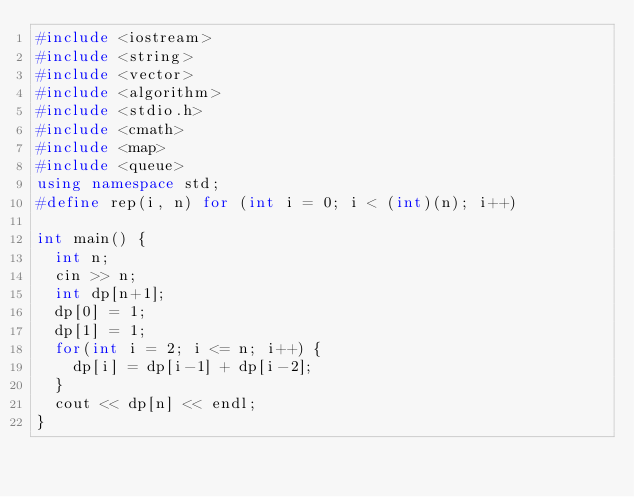<code> <loc_0><loc_0><loc_500><loc_500><_C++_>#include <iostream>
#include <string>
#include <vector>
#include <algorithm>
#include <stdio.h>
#include <cmath>
#include <map>
#include <queue>
using namespace std;
#define rep(i, n) for (int i = 0; i < (int)(n); i++)

int main() {
  int n;
  cin >> n;
  int dp[n+1];
  dp[0] = 1;
  dp[1] = 1;
  for(int i = 2; i <= n; i++) {
    dp[i] = dp[i-1] + dp[i-2];
  }
  cout << dp[n] << endl;
}
</code> 